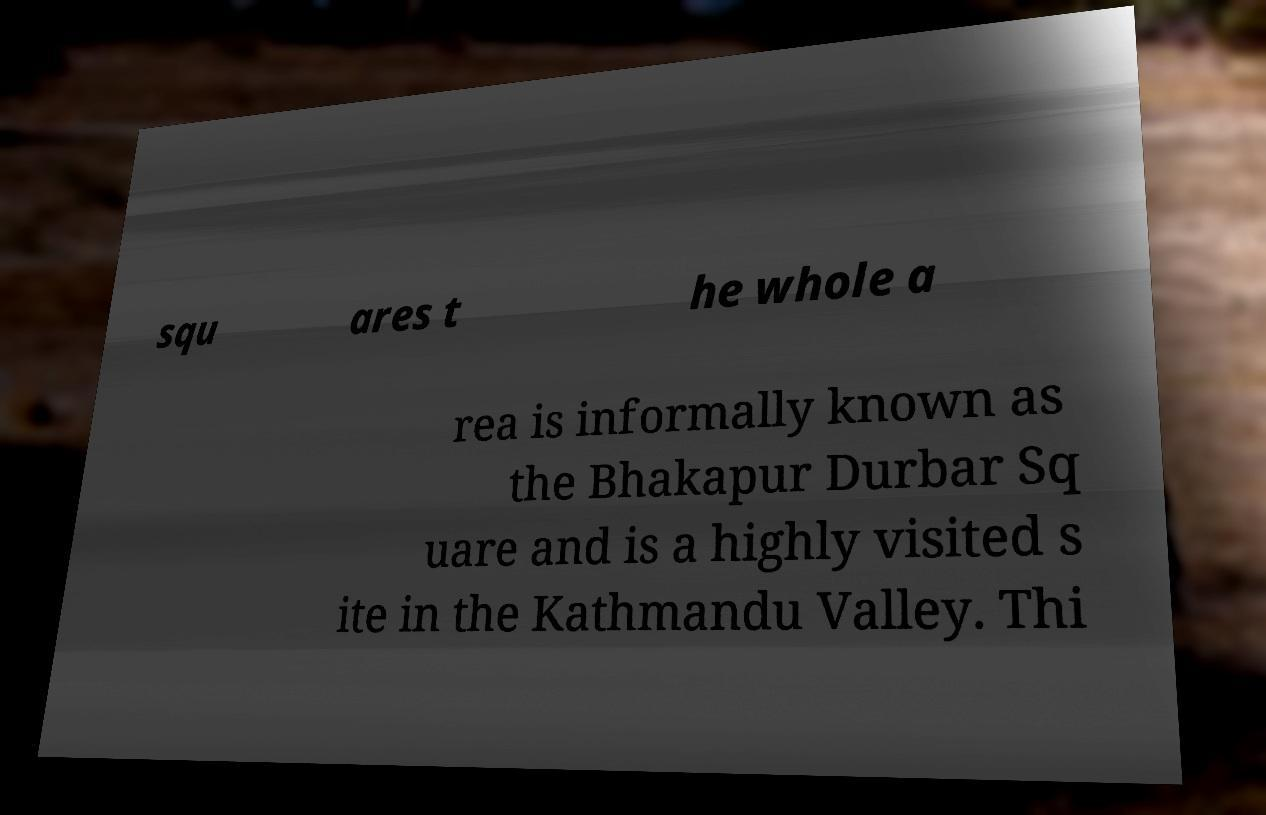There's text embedded in this image that I need extracted. Can you transcribe it verbatim? squ ares t he whole a rea is informally known as the Bhakapur Durbar Sq uare and is a highly visited s ite in the Kathmandu Valley. Thi 